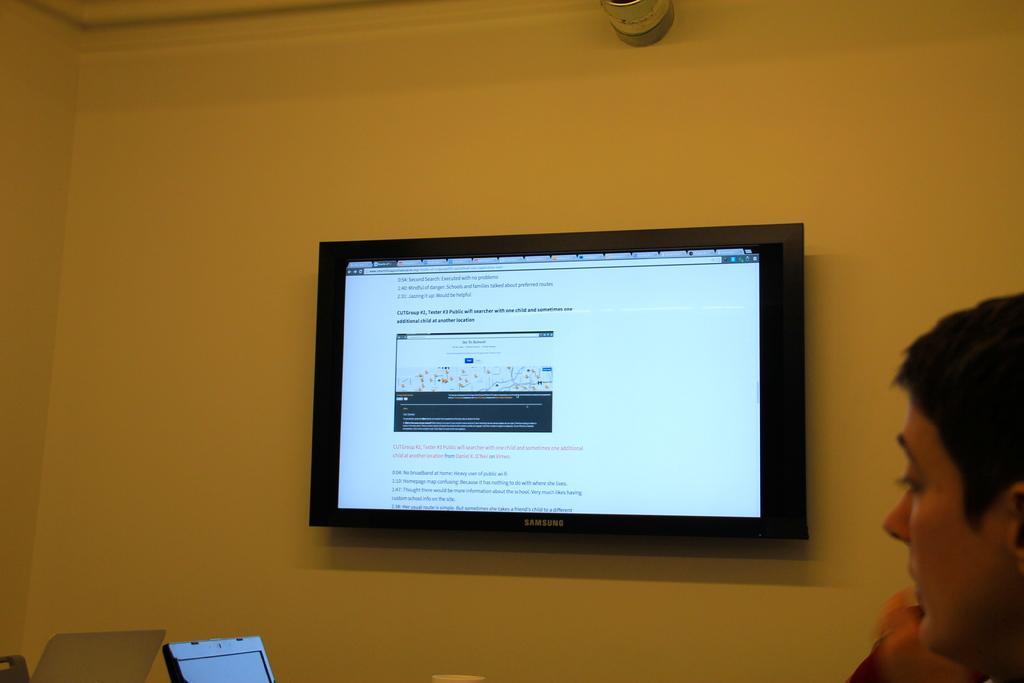What is the main object on the wall in the image? There is a TV on the wall in the center of the image. Can you describe the person in the image? There is a person on the right side of the image. What electronic device is located at the bottom of the image? There is a laptop at the bottom of the image. Is the person in the image walking through quicksand? There is no quicksand present in the image, and the person is not depicted as walking through any substance. 